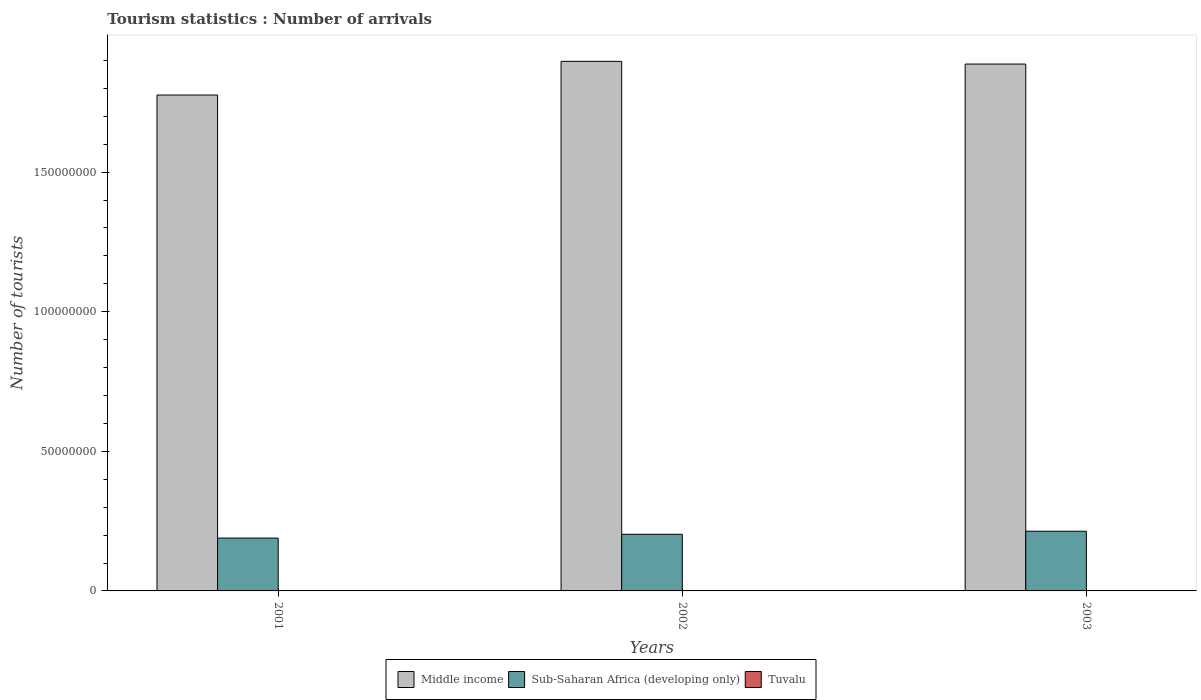How many groups of bars are there?
Offer a terse response. 3. Are the number of bars on each tick of the X-axis equal?
Make the answer very short. Yes. How many bars are there on the 3rd tick from the left?
Provide a short and direct response. 3. How many bars are there on the 1st tick from the right?
Ensure brevity in your answer.  3. In how many cases, is the number of bars for a given year not equal to the number of legend labels?
Ensure brevity in your answer.  0. What is the number of tourist arrivals in Middle income in 2001?
Keep it short and to the point. 1.78e+08. Across all years, what is the maximum number of tourist arrivals in Middle income?
Provide a succinct answer. 1.90e+08. Across all years, what is the minimum number of tourist arrivals in Middle income?
Your answer should be very brief. 1.78e+08. In which year was the number of tourist arrivals in Middle income maximum?
Give a very brief answer. 2002. In which year was the number of tourist arrivals in Tuvalu minimum?
Ensure brevity in your answer.  2001. What is the total number of tourist arrivals in Sub-Saharan Africa (developing only) in the graph?
Provide a short and direct response. 6.06e+07. What is the difference between the number of tourist arrivals in Middle income in 2001 and that in 2003?
Your answer should be very brief. -1.11e+07. What is the difference between the number of tourist arrivals in Tuvalu in 2003 and the number of tourist arrivals in Middle income in 2002?
Your answer should be compact. -1.90e+08. What is the average number of tourist arrivals in Middle income per year?
Your answer should be very brief. 1.85e+08. In the year 2003, what is the difference between the number of tourist arrivals in Tuvalu and number of tourist arrivals in Middle income?
Your response must be concise. -1.89e+08. What is the ratio of the number of tourist arrivals in Sub-Saharan Africa (developing only) in 2001 to that in 2002?
Keep it short and to the point. 0.93. Is the number of tourist arrivals in Middle income in 2001 less than that in 2002?
Provide a short and direct response. Yes. Is the difference between the number of tourist arrivals in Tuvalu in 2001 and 2002 greater than the difference between the number of tourist arrivals in Middle income in 2001 and 2002?
Offer a terse response. Yes. What is the difference between the highest and the second highest number of tourist arrivals in Middle income?
Ensure brevity in your answer.  9.66e+05. What is the difference between the highest and the lowest number of tourist arrivals in Middle income?
Provide a succinct answer. 1.21e+07. What does the 3rd bar from the right in 2001 represents?
Give a very brief answer. Middle income. Does the graph contain grids?
Your answer should be very brief. No. How many legend labels are there?
Provide a succinct answer. 3. How are the legend labels stacked?
Your answer should be compact. Horizontal. What is the title of the graph?
Your answer should be very brief. Tourism statistics : Number of arrivals. Does "Faeroe Islands" appear as one of the legend labels in the graph?
Provide a succinct answer. No. What is the label or title of the X-axis?
Give a very brief answer. Years. What is the label or title of the Y-axis?
Offer a terse response. Number of tourists. What is the Number of tourists of Middle income in 2001?
Provide a short and direct response. 1.78e+08. What is the Number of tourists of Sub-Saharan Africa (developing only) in 2001?
Your answer should be compact. 1.89e+07. What is the Number of tourists of Tuvalu in 2001?
Your answer should be compact. 1100. What is the Number of tourists in Middle income in 2002?
Your response must be concise. 1.90e+08. What is the Number of tourists in Sub-Saharan Africa (developing only) in 2002?
Keep it short and to the point. 2.03e+07. What is the Number of tourists in Tuvalu in 2002?
Your answer should be very brief. 1300. What is the Number of tourists of Middle income in 2003?
Your answer should be very brief. 1.89e+08. What is the Number of tourists in Sub-Saharan Africa (developing only) in 2003?
Keep it short and to the point. 2.14e+07. What is the Number of tourists of Tuvalu in 2003?
Give a very brief answer. 1400. Across all years, what is the maximum Number of tourists in Middle income?
Make the answer very short. 1.90e+08. Across all years, what is the maximum Number of tourists of Sub-Saharan Africa (developing only)?
Keep it short and to the point. 2.14e+07. Across all years, what is the maximum Number of tourists in Tuvalu?
Your answer should be very brief. 1400. Across all years, what is the minimum Number of tourists of Middle income?
Give a very brief answer. 1.78e+08. Across all years, what is the minimum Number of tourists of Sub-Saharan Africa (developing only)?
Your response must be concise. 1.89e+07. Across all years, what is the minimum Number of tourists in Tuvalu?
Provide a short and direct response. 1100. What is the total Number of tourists of Middle income in the graph?
Provide a succinct answer. 5.56e+08. What is the total Number of tourists in Sub-Saharan Africa (developing only) in the graph?
Offer a terse response. 6.06e+07. What is the total Number of tourists of Tuvalu in the graph?
Your answer should be very brief. 3800. What is the difference between the Number of tourists of Middle income in 2001 and that in 2002?
Offer a very short reply. -1.21e+07. What is the difference between the Number of tourists in Sub-Saharan Africa (developing only) in 2001 and that in 2002?
Provide a short and direct response. -1.35e+06. What is the difference between the Number of tourists of Tuvalu in 2001 and that in 2002?
Make the answer very short. -200. What is the difference between the Number of tourists of Middle income in 2001 and that in 2003?
Your answer should be very brief. -1.11e+07. What is the difference between the Number of tourists of Sub-Saharan Africa (developing only) in 2001 and that in 2003?
Provide a short and direct response. -2.45e+06. What is the difference between the Number of tourists in Tuvalu in 2001 and that in 2003?
Make the answer very short. -300. What is the difference between the Number of tourists of Middle income in 2002 and that in 2003?
Your response must be concise. 9.66e+05. What is the difference between the Number of tourists in Sub-Saharan Africa (developing only) in 2002 and that in 2003?
Make the answer very short. -1.10e+06. What is the difference between the Number of tourists in Tuvalu in 2002 and that in 2003?
Provide a succinct answer. -100. What is the difference between the Number of tourists in Middle income in 2001 and the Number of tourists in Sub-Saharan Africa (developing only) in 2002?
Offer a very short reply. 1.57e+08. What is the difference between the Number of tourists of Middle income in 2001 and the Number of tourists of Tuvalu in 2002?
Provide a succinct answer. 1.78e+08. What is the difference between the Number of tourists in Sub-Saharan Africa (developing only) in 2001 and the Number of tourists in Tuvalu in 2002?
Your response must be concise. 1.89e+07. What is the difference between the Number of tourists of Middle income in 2001 and the Number of tourists of Sub-Saharan Africa (developing only) in 2003?
Provide a succinct answer. 1.56e+08. What is the difference between the Number of tourists of Middle income in 2001 and the Number of tourists of Tuvalu in 2003?
Your answer should be compact. 1.78e+08. What is the difference between the Number of tourists in Sub-Saharan Africa (developing only) in 2001 and the Number of tourists in Tuvalu in 2003?
Offer a very short reply. 1.89e+07. What is the difference between the Number of tourists of Middle income in 2002 and the Number of tourists of Sub-Saharan Africa (developing only) in 2003?
Offer a terse response. 1.68e+08. What is the difference between the Number of tourists in Middle income in 2002 and the Number of tourists in Tuvalu in 2003?
Make the answer very short. 1.90e+08. What is the difference between the Number of tourists of Sub-Saharan Africa (developing only) in 2002 and the Number of tourists of Tuvalu in 2003?
Make the answer very short. 2.03e+07. What is the average Number of tourists of Middle income per year?
Keep it short and to the point. 1.85e+08. What is the average Number of tourists in Sub-Saharan Africa (developing only) per year?
Your answer should be very brief. 2.02e+07. What is the average Number of tourists in Tuvalu per year?
Ensure brevity in your answer.  1266.67. In the year 2001, what is the difference between the Number of tourists of Middle income and Number of tourists of Sub-Saharan Africa (developing only)?
Ensure brevity in your answer.  1.59e+08. In the year 2001, what is the difference between the Number of tourists of Middle income and Number of tourists of Tuvalu?
Provide a short and direct response. 1.78e+08. In the year 2001, what is the difference between the Number of tourists in Sub-Saharan Africa (developing only) and Number of tourists in Tuvalu?
Keep it short and to the point. 1.89e+07. In the year 2002, what is the difference between the Number of tourists of Middle income and Number of tourists of Sub-Saharan Africa (developing only)?
Offer a very short reply. 1.69e+08. In the year 2002, what is the difference between the Number of tourists of Middle income and Number of tourists of Tuvalu?
Your response must be concise. 1.90e+08. In the year 2002, what is the difference between the Number of tourists in Sub-Saharan Africa (developing only) and Number of tourists in Tuvalu?
Provide a short and direct response. 2.03e+07. In the year 2003, what is the difference between the Number of tourists in Middle income and Number of tourists in Sub-Saharan Africa (developing only)?
Make the answer very short. 1.67e+08. In the year 2003, what is the difference between the Number of tourists of Middle income and Number of tourists of Tuvalu?
Make the answer very short. 1.89e+08. In the year 2003, what is the difference between the Number of tourists in Sub-Saharan Africa (developing only) and Number of tourists in Tuvalu?
Your response must be concise. 2.14e+07. What is the ratio of the Number of tourists in Middle income in 2001 to that in 2002?
Provide a short and direct response. 0.94. What is the ratio of the Number of tourists of Sub-Saharan Africa (developing only) in 2001 to that in 2002?
Your response must be concise. 0.93. What is the ratio of the Number of tourists in Tuvalu in 2001 to that in 2002?
Offer a terse response. 0.85. What is the ratio of the Number of tourists in Middle income in 2001 to that in 2003?
Your answer should be very brief. 0.94. What is the ratio of the Number of tourists of Sub-Saharan Africa (developing only) in 2001 to that in 2003?
Offer a very short reply. 0.89. What is the ratio of the Number of tourists of Tuvalu in 2001 to that in 2003?
Your answer should be compact. 0.79. What is the ratio of the Number of tourists in Sub-Saharan Africa (developing only) in 2002 to that in 2003?
Offer a terse response. 0.95. What is the difference between the highest and the second highest Number of tourists of Middle income?
Ensure brevity in your answer.  9.66e+05. What is the difference between the highest and the second highest Number of tourists in Sub-Saharan Africa (developing only)?
Offer a very short reply. 1.10e+06. What is the difference between the highest and the second highest Number of tourists in Tuvalu?
Your response must be concise. 100. What is the difference between the highest and the lowest Number of tourists of Middle income?
Your answer should be very brief. 1.21e+07. What is the difference between the highest and the lowest Number of tourists of Sub-Saharan Africa (developing only)?
Offer a very short reply. 2.45e+06. What is the difference between the highest and the lowest Number of tourists in Tuvalu?
Your answer should be very brief. 300. 